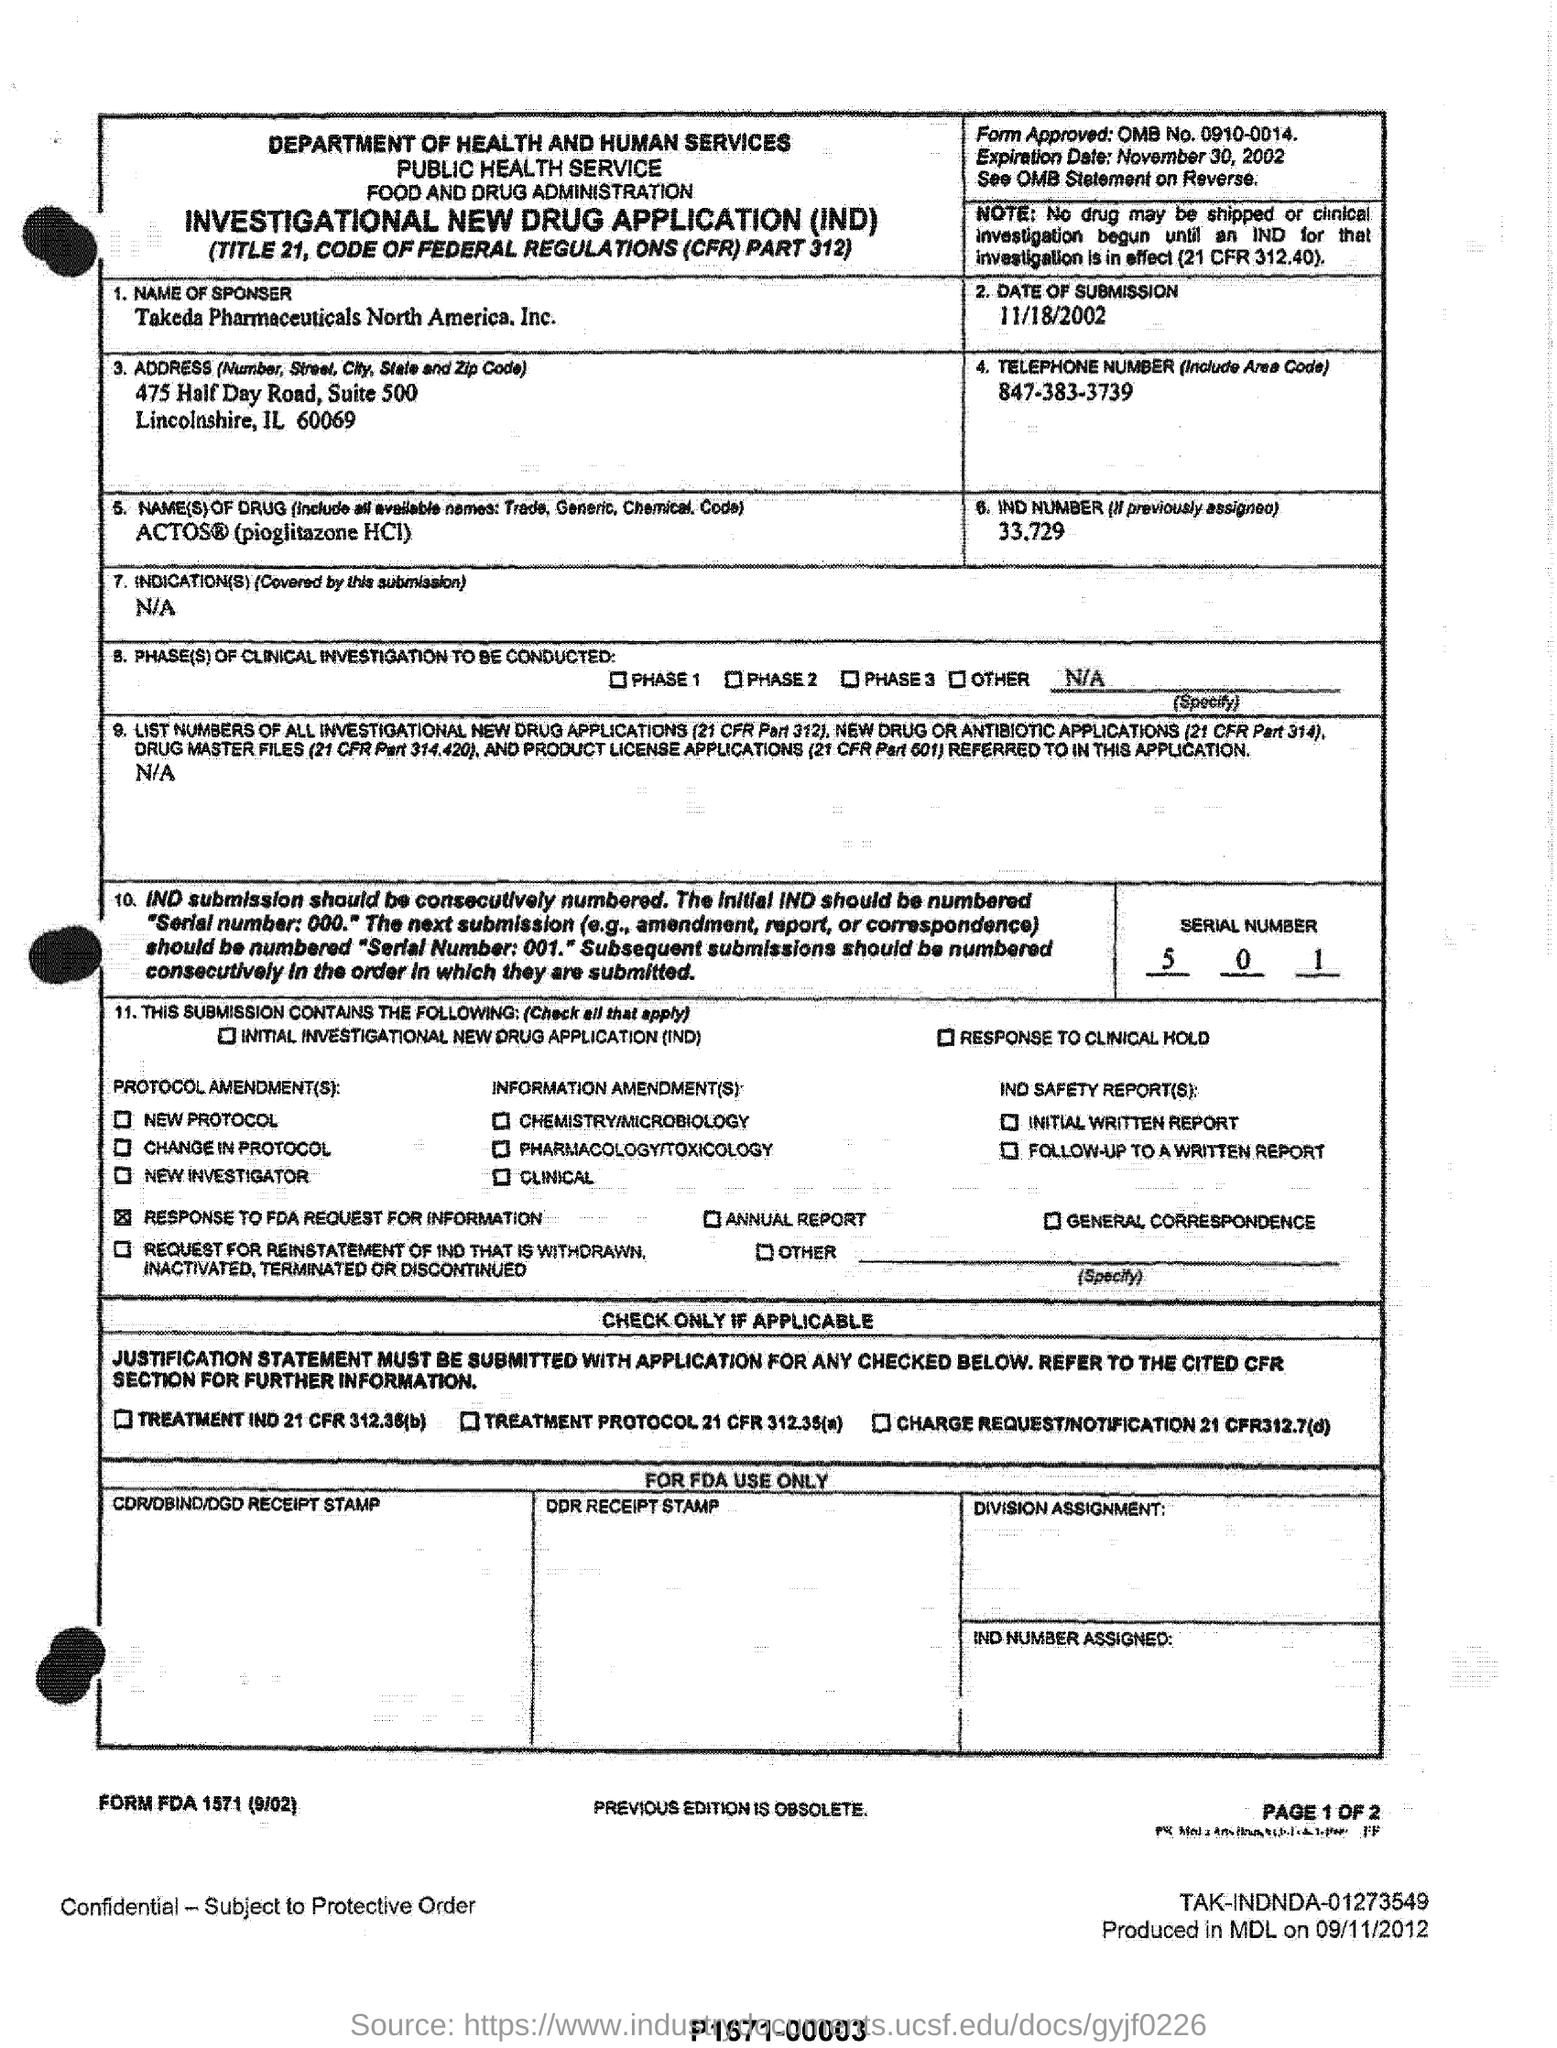To which department it belongs to ?
Give a very brief answer. Department of health and human services. What is the date of submission?
Your response must be concise. 11/18/2002. What is the telephone number (include area code)?
Give a very brief answer. 847-383-3739. What is the serial number mentioned in the form?
Your answer should be very brief. 5 0 1. What is the expiration date ?
Your answer should be very brief. November 30, 2002. What is  the name of the sponsor ?
Provide a short and direct response. Takeda Pharmaceuticals North America, Inc. 